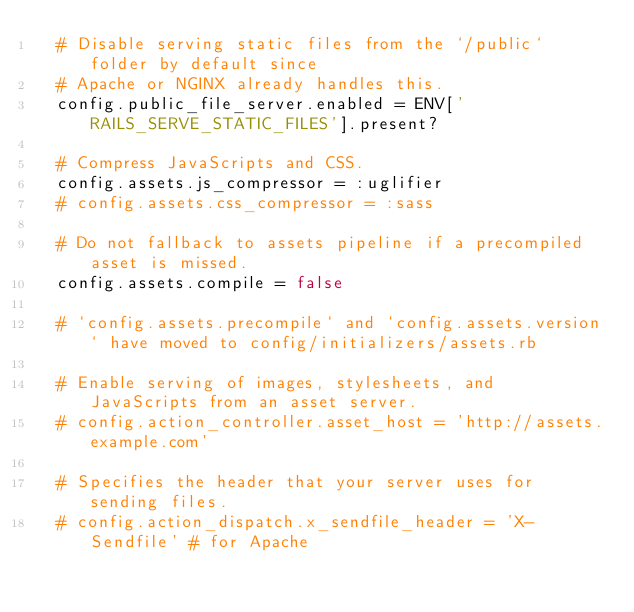Convert code to text. <code><loc_0><loc_0><loc_500><loc_500><_Ruby_>  # Disable serving static files from the `/public` folder by default since
  # Apache or NGINX already handles this.
  config.public_file_server.enabled = ENV['RAILS_SERVE_STATIC_FILES'].present?

  # Compress JavaScripts and CSS.
  config.assets.js_compressor = :uglifier
  # config.assets.css_compressor = :sass

  # Do not fallback to assets pipeline if a precompiled asset is missed.
  config.assets.compile = false

  # `config.assets.precompile` and `config.assets.version` have moved to config/initializers/assets.rb

  # Enable serving of images, stylesheets, and JavaScripts from an asset server.
  # config.action_controller.asset_host = 'http://assets.example.com'

  # Specifies the header that your server uses for sending files.
  # config.action_dispatch.x_sendfile_header = 'X-Sendfile' # for Apache</code> 